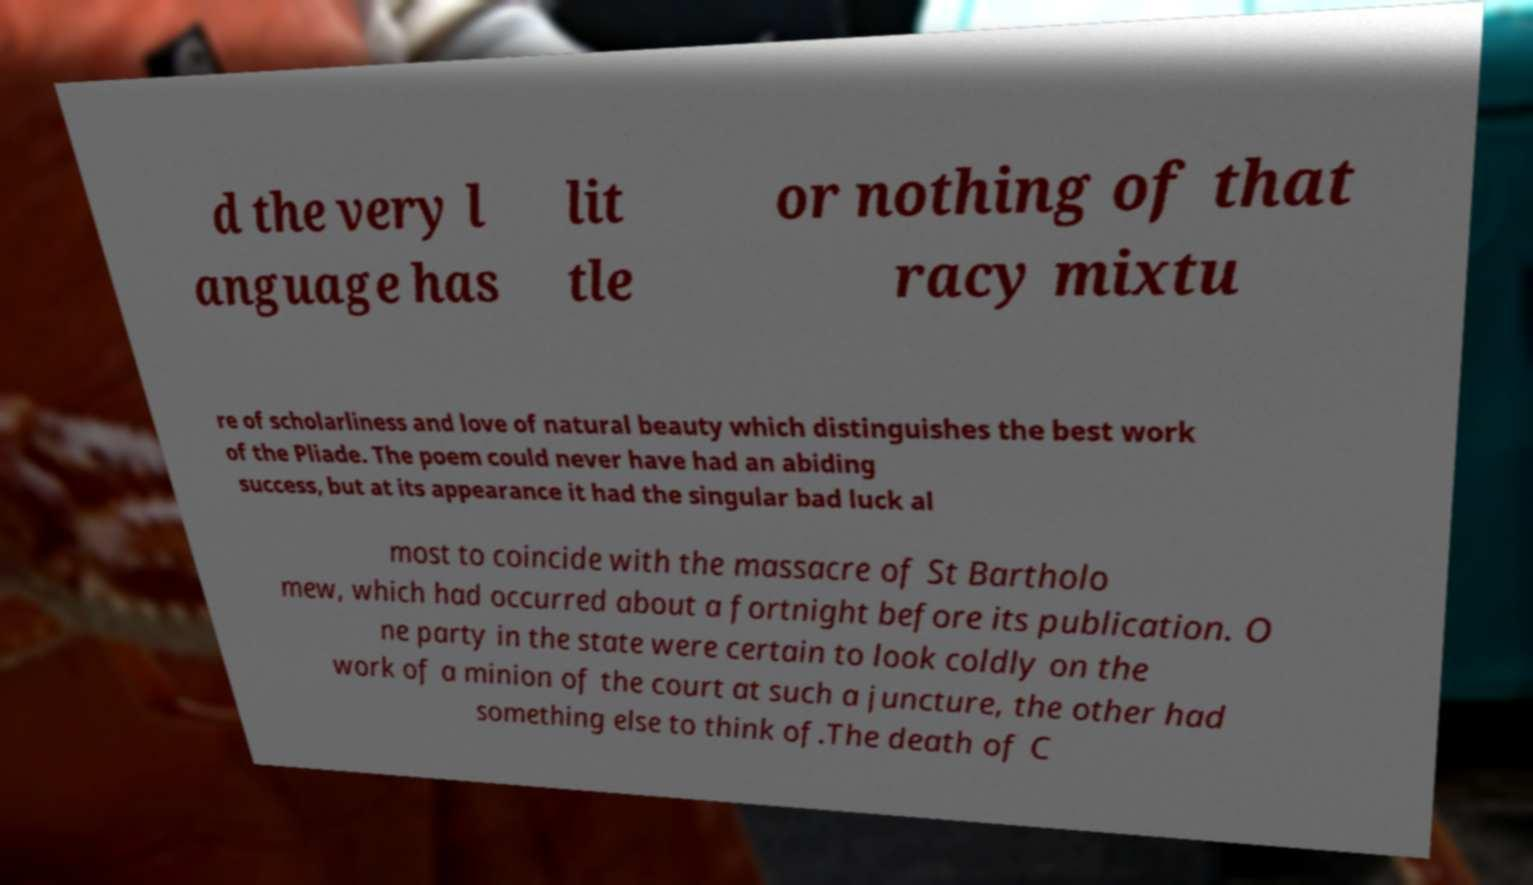There's text embedded in this image that I need extracted. Can you transcribe it verbatim? d the very l anguage has lit tle or nothing of that racy mixtu re of scholarliness and love of natural beauty which distinguishes the best work of the Pliade. The poem could never have had an abiding success, but at its appearance it had the singular bad luck al most to coincide with the massacre of St Bartholo mew, which had occurred about a fortnight before its publication. O ne party in the state were certain to look coldly on the work of a minion of the court at such a juncture, the other had something else to think of.The death of C 